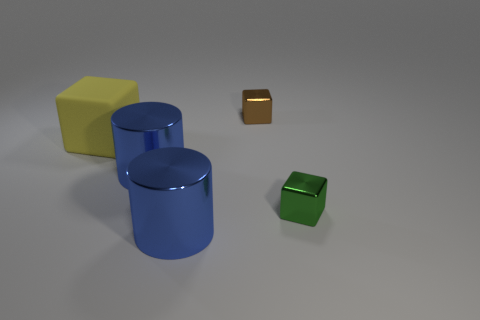How many other things are there of the same size as the yellow cube?
Ensure brevity in your answer.  2. What is the color of the small thing that is on the right side of the small brown thing?
Provide a short and direct response. Green. Does the small object on the right side of the small brown thing have the same material as the small brown cube?
Provide a succinct answer. Yes. What number of objects are left of the brown metallic thing and in front of the large yellow thing?
Keep it short and to the point. 2. What color is the tiny object that is to the left of the shiny object to the right of the tiny metallic thing that is behind the yellow cube?
Your answer should be compact. Brown. Is there a metal thing to the right of the block that is behind the large matte cube?
Your response must be concise. Yes. How many shiny objects are either blue objects or small brown things?
Offer a very short reply. 3. There is a cube that is both behind the green block and in front of the brown shiny thing; what is its material?
Offer a very short reply. Rubber. Is there a big blue shiny cylinder behind the cylinder that is in front of the metal cylinder behind the small green thing?
Your answer should be very brief. Yes. Are there any other things that have the same material as the yellow block?
Offer a terse response. No. 